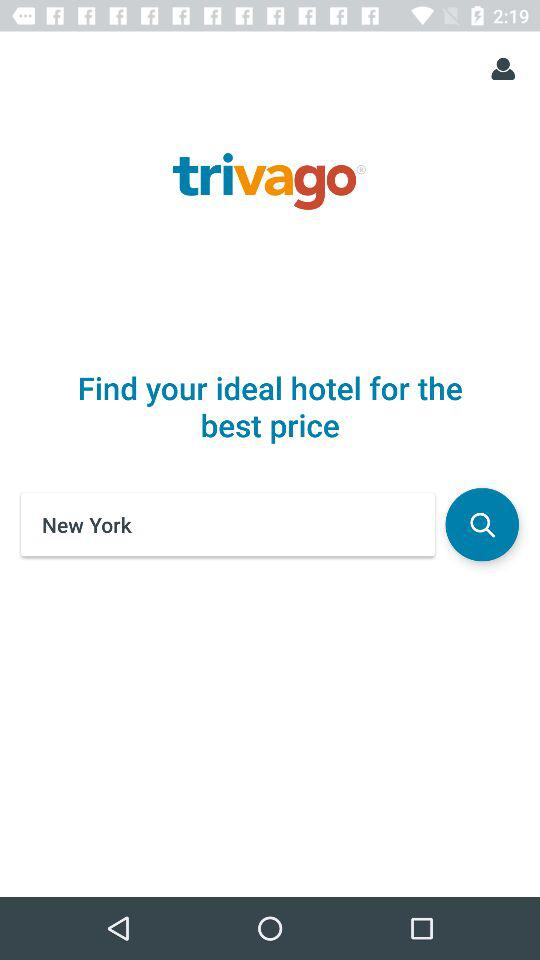What location is entered in the search bar? The location that is entered in the search bar is New York. 